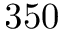Convert formula to latex. <formula><loc_0><loc_0><loc_500><loc_500>3 5 0</formula> 